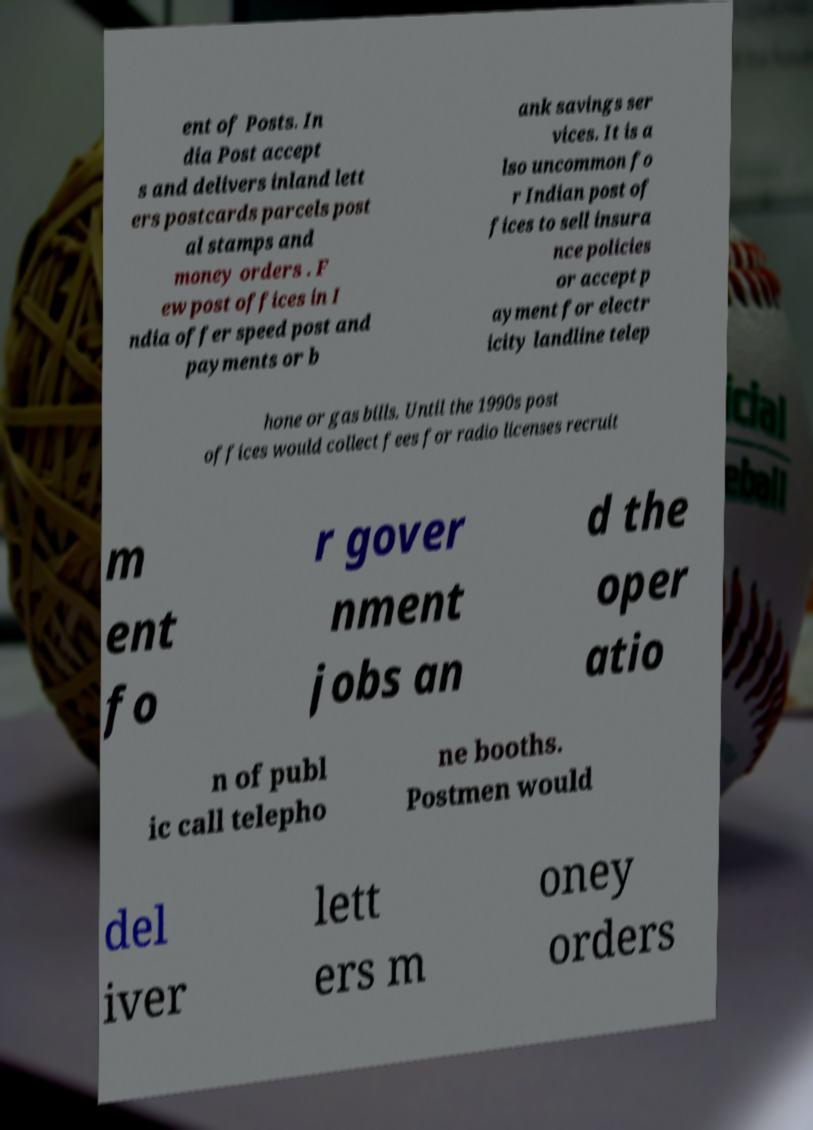Could you assist in decoding the text presented in this image and type it out clearly? ent of Posts. In dia Post accept s and delivers inland lett ers postcards parcels post al stamps and money orders . F ew post offices in I ndia offer speed post and payments or b ank savings ser vices. It is a lso uncommon fo r Indian post of fices to sell insura nce policies or accept p ayment for electr icity landline telep hone or gas bills. Until the 1990s post offices would collect fees for radio licenses recruit m ent fo r gover nment jobs an d the oper atio n of publ ic call telepho ne booths. Postmen would del iver lett ers m oney orders 